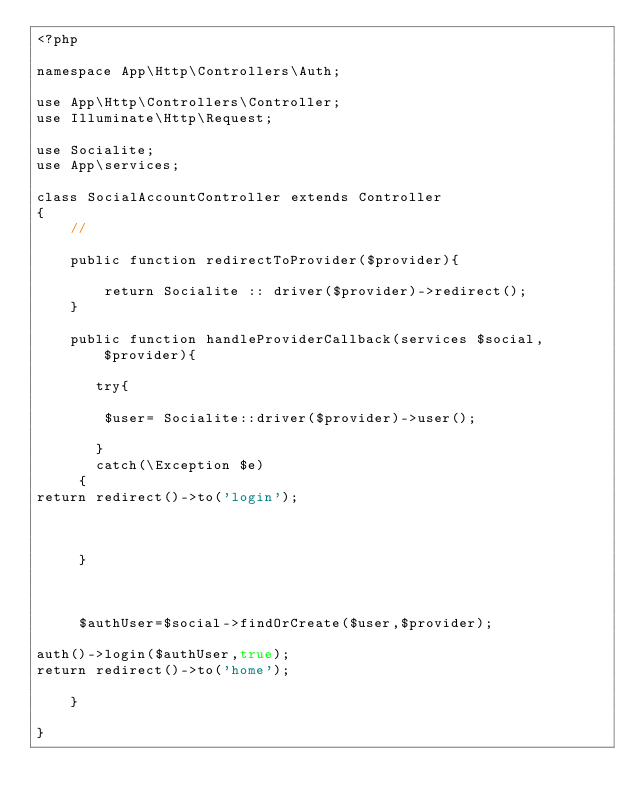Convert code to text. <code><loc_0><loc_0><loc_500><loc_500><_PHP_><?php

namespace App\Http\Controllers\Auth;

use App\Http\Controllers\Controller;
use Illuminate\Http\Request;

use Socialite;
use App\services;

class SocialAccountController extends Controller
{
    //

    public function redirectToProvider($provider){

        return Socialite :: driver($provider)->redirect();
    }

    public function handleProviderCallback(services $social,$provider){

       try{

        $user= Socialite::driver($provider)->user();
    
       }
       catch(\Exception $e)
     {
return redirect()->to('login');



     }


     
     $authUser=$social->findOrCreate($user,$provider);

auth()->login($authUser,true);
return redirect()->to('home');

    }

}
</code> 